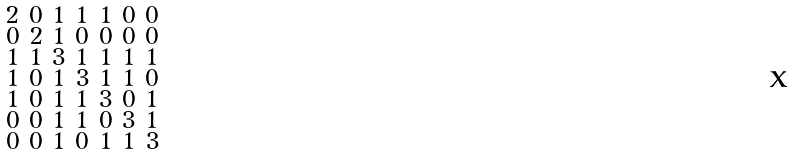<formula> <loc_0><loc_0><loc_500><loc_500>\begin{smallmatrix} 2 & 0 & 1 & 1 & 1 & 0 & 0 \\ 0 & 2 & 1 & 0 & 0 & 0 & 0 \\ 1 & 1 & 3 & 1 & 1 & 1 & 1 \\ 1 & 0 & 1 & 3 & 1 & 1 & 0 \\ 1 & 0 & 1 & 1 & 3 & 0 & 1 \\ 0 & 0 & 1 & 1 & 0 & 3 & 1 \\ 0 & 0 & 1 & 0 & 1 & 1 & 3 \end{smallmatrix}</formula> 